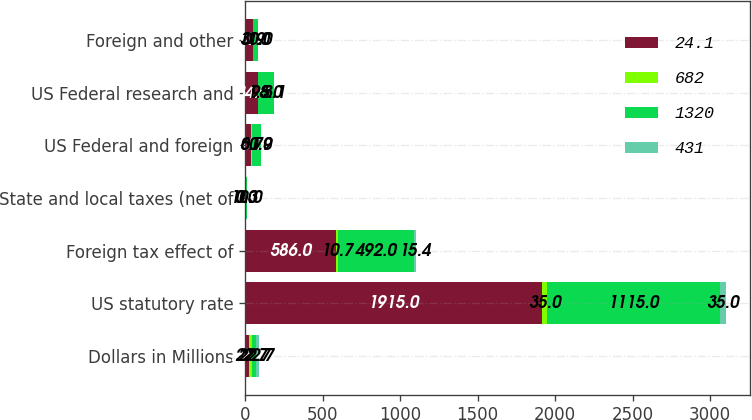Convert chart. <chart><loc_0><loc_0><loc_500><loc_500><stacked_bar_chart><ecel><fcel>Dollars in Millions<fcel>US statutory rate<fcel>Foreign tax effect of<fcel>State and local taxes (net of<fcel>US Federal and foreign<fcel>US Federal research and<fcel>Foreign and other<nl><fcel>24.1<fcel>22.7<fcel>1915<fcel>586<fcel>1<fcel>40<fcel>84<fcel>52<nl><fcel>682<fcel>22.7<fcel>35<fcel>10.7<fcel>0<fcel>0.7<fcel>1.5<fcel>0.9<nl><fcel>1320<fcel>22.7<fcel>1115<fcel>492<fcel>10<fcel>60<fcel>98<fcel>30<nl><fcel>431<fcel>22.7<fcel>35<fcel>15.4<fcel>0.3<fcel>1.9<fcel>3.1<fcel>1<nl></chart> 